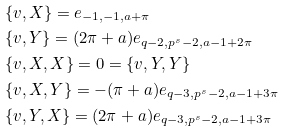<formula> <loc_0><loc_0><loc_500><loc_500>& \{ v , X \} = e _ { - 1 , - 1 , a + \pi } \\ & \{ v , Y \} = ( 2 \pi + a ) e _ { q - 2 , p ^ { s } - 2 , a - 1 + 2 \pi } \\ & \{ v , X , X \} = 0 = \{ v , Y , Y \} \\ & \{ v , X , Y \} = - ( \pi + a ) e _ { q - 3 , p ^ { s } - 2 , a - 1 + 3 \pi } \\ & \{ v , Y , X \} = ( 2 \pi + a ) e _ { q - 3 , p ^ { s } - 2 , a - 1 + 3 \pi }</formula> 